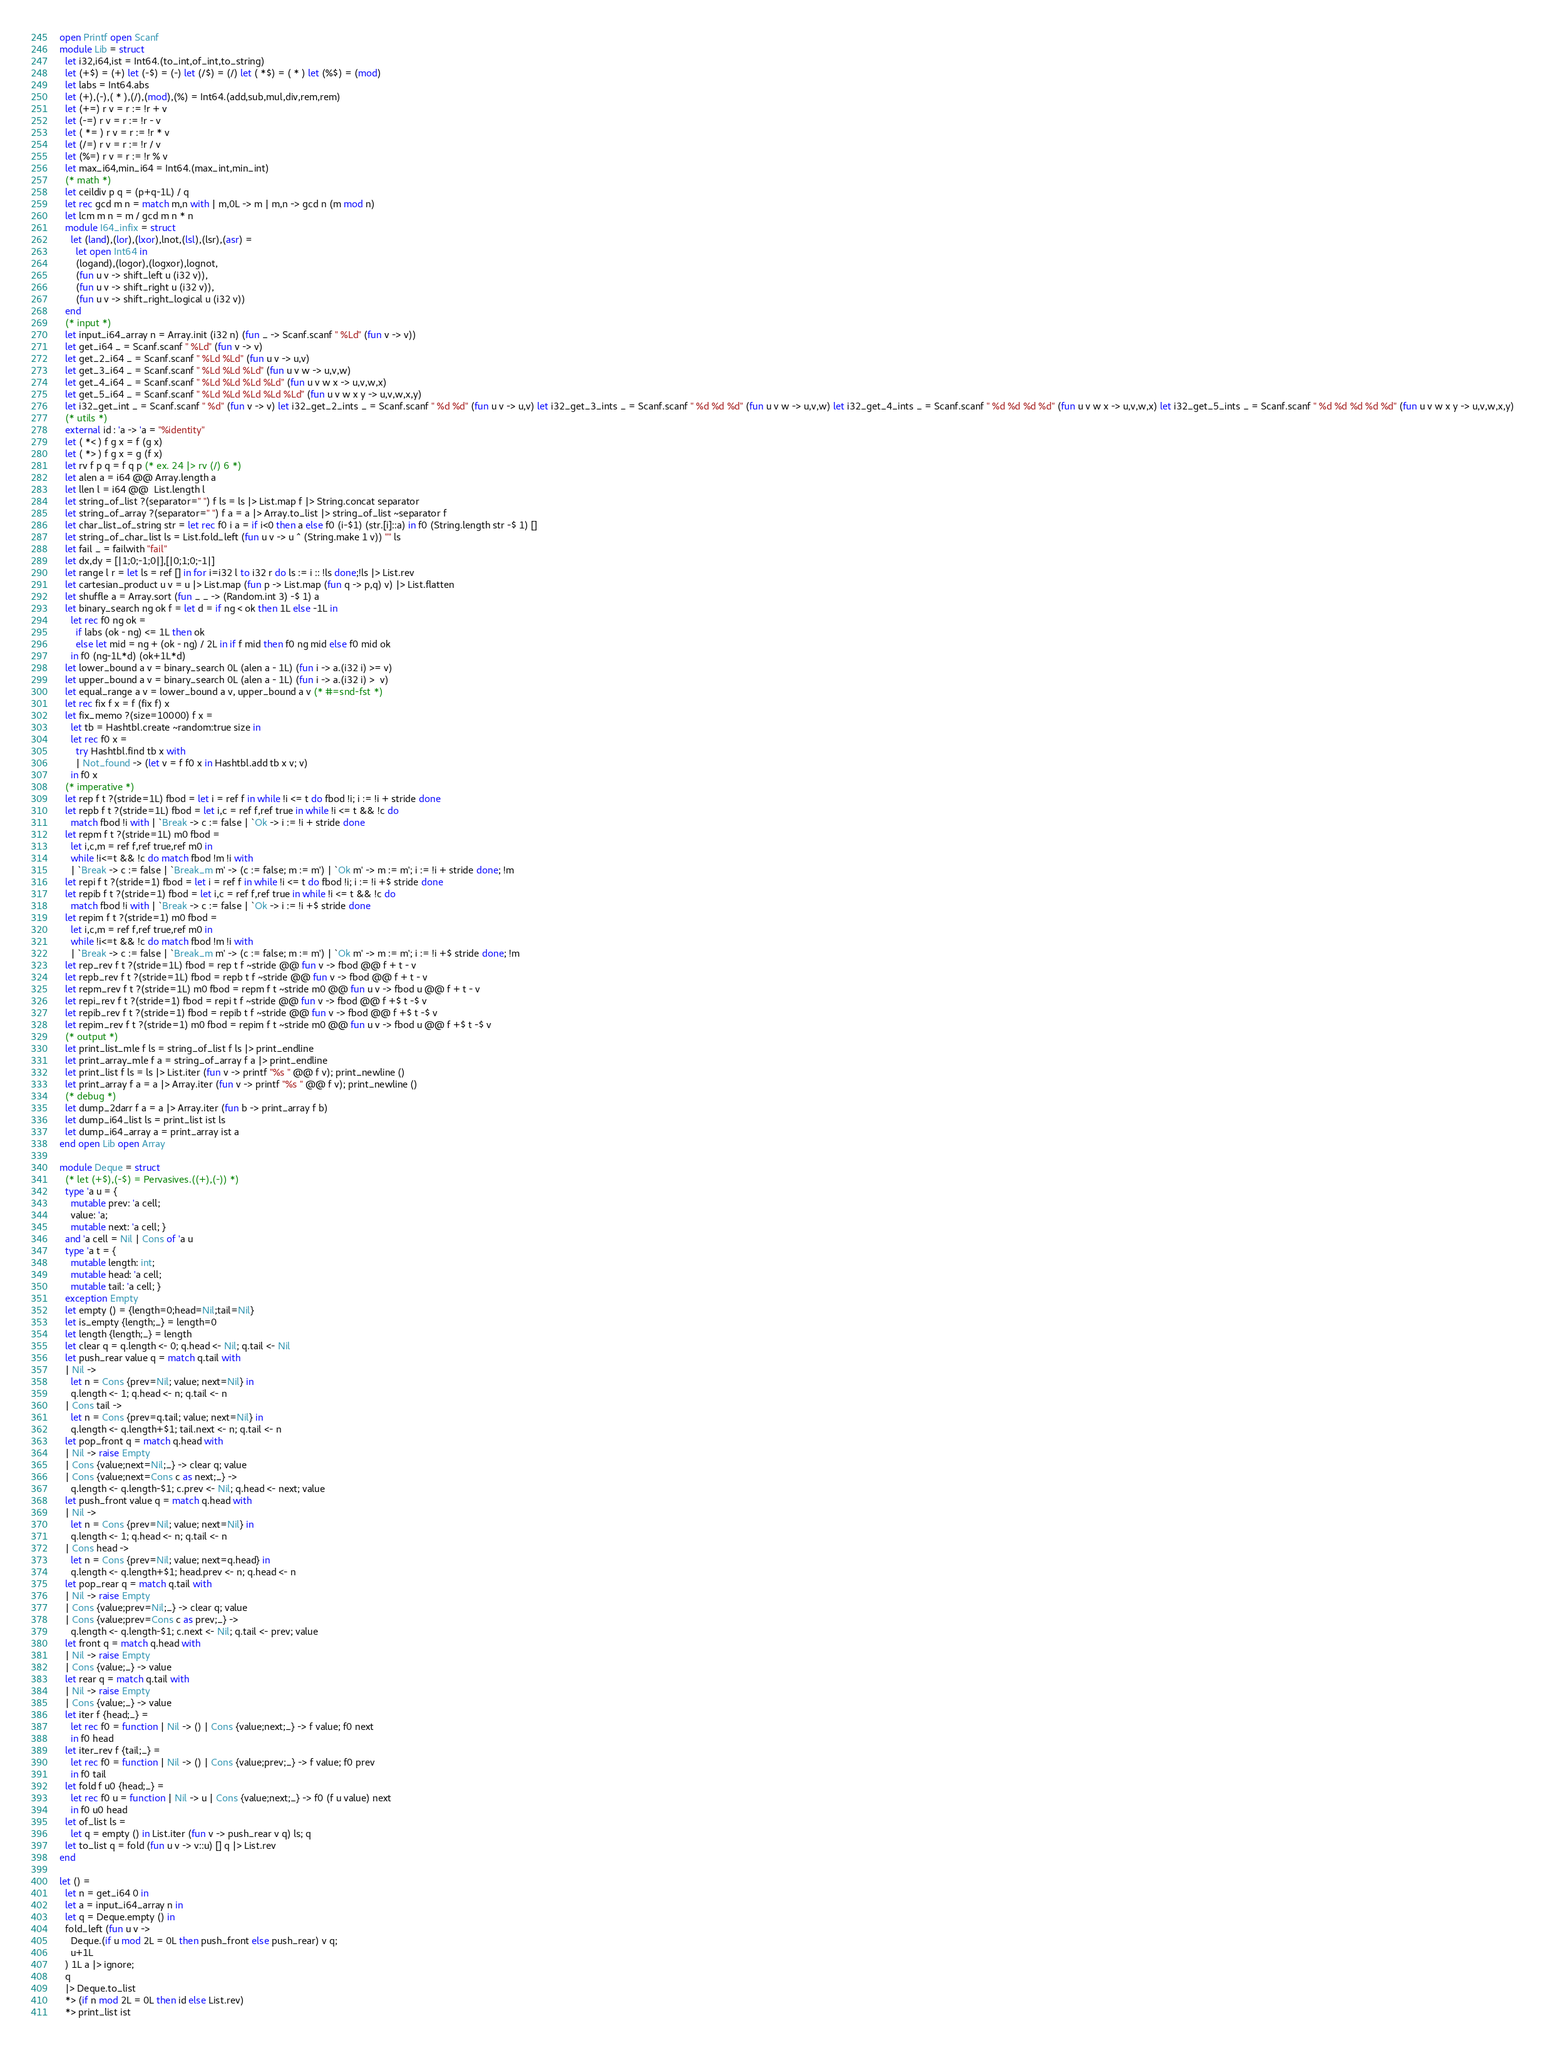<code> <loc_0><loc_0><loc_500><loc_500><_OCaml_>open Printf open Scanf
module Lib = struct
  let i32,i64,ist = Int64.(to_int,of_int,to_string)
  let (+$) = (+) let (-$) = (-) let (/$) = (/) let ( *$) = ( * ) let (%$) = (mod)
  let labs = Int64.abs
  let (+),(-),( * ),(/),(mod),(%) = Int64.(add,sub,mul,div,rem,rem)
  let (+=) r v = r := !r + v
  let (-=) r v = r := !r - v
  let ( *= ) r v = r := !r * v
  let (/=) r v = r := !r / v
  let (%=) r v = r := !r % v
  let max_i64,min_i64 = Int64.(max_int,min_int)
  (* math *)
  let ceildiv p q = (p+q-1L) / q
  let rec gcd m n = match m,n with | m,0L -> m | m,n -> gcd n (m mod n)
  let lcm m n = m / gcd m n * n
  module I64_infix = struct
    let (land),(lor),(lxor),lnot,(lsl),(lsr),(asr) =
      let open Int64 in
      (logand),(logor),(logxor),lognot,
      (fun u v -> shift_left u (i32 v)),
      (fun u v -> shift_right u (i32 v)),
      (fun u v -> shift_right_logical u (i32 v))
  end
  (* input *)
  let input_i64_array n = Array.init (i32 n) (fun _ -> Scanf.scanf " %Ld" (fun v -> v))
  let get_i64 _ = Scanf.scanf " %Ld" (fun v -> v)
  let get_2_i64 _ = Scanf.scanf " %Ld %Ld" (fun u v -> u,v)
  let get_3_i64 _ = Scanf.scanf " %Ld %Ld %Ld" (fun u v w -> u,v,w)
  let get_4_i64 _ = Scanf.scanf " %Ld %Ld %Ld %Ld" (fun u v w x -> u,v,w,x)
  let get_5_i64 _ = Scanf.scanf " %Ld %Ld %Ld %Ld %Ld" (fun u v w x y -> u,v,w,x,y)
  let i32_get_int _ = Scanf.scanf " %d" (fun v -> v) let i32_get_2_ints _ = Scanf.scanf " %d %d" (fun u v -> u,v) let i32_get_3_ints _ = Scanf.scanf " %d %d %d" (fun u v w -> u,v,w) let i32_get_4_ints _ = Scanf.scanf " %d %d %d %d" (fun u v w x -> u,v,w,x) let i32_get_5_ints _ = Scanf.scanf " %d %d %d %d %d" (fun u v w x y -> u,v,w,x,y)
  (* utils *)
  external id : 'a -> 'a = "%identity"
  let ( *< ) f g x = f (g x)
  let ( *> ) f g x = g (f x)
  let rv f p q = f q p (* ex. 24 |> rv (/) 6 *)
  let alen a = i64 @@ Array.length a
  let llen l = i64 @@  List.length l
  let string_of_list ?(separator=" ") f ls = ls |> List.map f |> String.concat separator
  let string_of_array ?(separator=" ") f a = a |> Array.to_list |> string_of_list ~separator f
  let char_list_of_string str = let rec f0 i a = if i<0 then a else f0 (i-$1) (str.[i]::a) in f0 (String.length str -$ 1) []
  let string_of_char_list ls = List.fold_left (fun u v -> u ^ (String.make 1 v)) "" ls
  let fail _ = failwith "fail"
  let dx,dy = [|1;0;-1;0|],[|0;1;0;-1|]
  let range l r = let ls = ref [] in for i=i32 l to i32 r do ls := i :: !ls done;!ls |> List.rev
  let cartesian_product u v = u |> List.map (fun p -> List.map (fun q -> p,q) v) |> List.flatten
  let shuffle a = Array.sort (fun _ _ -> (Random.int 3) -$ 1) a
  let binary_search ng ok f = let d = if ng < ok then 1L else -1L in
    let rec f0 ng ok =
      if labs (ok - ng) <= 1L then ok
      else let mid = ng + (ok - ng) / 2L in if f mid then f0 ng mid else f0 mid ok
    in f0 (ng-1L*d) (ok+1L*d)
  let lower_bound a v = binary_search 0L (alen a - 1L) (fun i -> a.(i32 i) >= v)
  let upper_bound a v = binary_search 0L (alen a - 1L) (fun i -> a.(i32 i) >  v)
  let equal_range a v = lower_bound a v, upper_bound a v (* #=snd-fst *)
  let rec fix f x = f (fix f) x
  let fix_memo ?(size=10000) f x =
    let tb = Hashtbl.create ~random:true size in
    let rec f0 x =
      try Hashtbl.find tb x with
      | Not_found -> (let v = f f0 x in Hashtbl.add tb x v; v)
    in f0 x
  (* imperative *)
  let rep f t ?(stride=1L) fbod = let i = ref f in while !i <= t do fbod !i; i := !i + stride done
  let repb f t ?(stride=1L) fbod = let i,c = ref f,ref true in while !i <= t && !c do
    match fbod !i with | `Break -> c := false | `Ok -> i := !i + stride done
  let repm f t ?(stride=1L) m0 fbod =
    let i,c,m = ref f,ref true,ref m0 in
    while !i<=t && !c do match fbod !m !i with
    | `Break -> c := false | `Break_m m' -> (c := false; m := m') | `Ok m' -> m := m'; i := !i + stride done; !m
  let repi f t ?(stride=1) fbod = let i = ref f in while !i <= t do fbod !i; i := !i +$ stride done
  let repib f t ?(stride=1) fbod = let i,c = ref f,ref true in while !i <= t && !c do
    match fbod !i with | `Break -> c := false | `Ok -> i := !i +$ stride done
  let repim f t ?(stride=1) m0 fbod =
    let i,c,m = ref f,ref true,ref m0 in
    while !i<=t && !c do match fbod !m !i with
    | `Break -> c := false | `Break_m m' -> (c := false; m := m') | `Ok m' -> m := m'; i := !i +$ stride done; !m
  let rep_rev f t ?(stride=1L) fbod = rep t f ~stride @@ fun v -> fbod @@ f + t - v
  let repb_rev f t ?(stride=1L) fbod = repb t f ~stride @@ fun v -> fbod @@ f + t - v
  let repm_rev f t ?(stride=1L) m0 fbod = repm f t ~stride m0 @@ fun u v -> fbod u @@ f + t - v
  let repi_rev f t ?(stride=1) fbod = repi t f ~stride @@ fun v -> fbod @@ f +$ t -$ v
  let repib_rev f t ?(stride=1) fbod = repib t f ~stride @@ fun v -> fbod @@ f +$ t -$ v
  let repim_rev f t ?(stride=1) m0 fbod = repim f t ~stride m0 @@ fun u v -> fbod u @@ f +$ t -$ v
  (* output *)
  let print_list_mle f ls = string_of_list f ls |> print_endline
  let print_array_mle f a = string_of_array f a |> print_endline
  let print_list f ls = ls |> List.iter (fun v -> printf "%s " @@ f v); print_newline ()
  let print_array f a = a |> Array.iter (fun v -> printf "%s " @@ f v); print_newline ()
  (* debug *)
  let dump_2darr f a = a |> Array.iter (fun b -> print_array f b)
  let dump_i64_list ls = print_list ist ls
  let dump_i64_array a = print_array ist a
end open Lib open Array

module Deque = struct
  (* let (+$),(-$) = Pervasives.((+),(-)) *)
  type 'a u = {
    mutable prev: 'a cell;
    value: 'a;
    mutable next: 'a cell; }
  and 'a cell = Nil | Cons of 'a u
  type 'a t = {
    mutable length: int;
    mutable head: 'a cell;
    mutable tail: 'a cell; }
  exception Empty
  let empty () = {length=0;head=Nil;tail=Nil}
  let is_empty {length;_} = length=0
  let length {length;_} = length
  let clear q = q.length <- 0; q.head <- Nil; q.tail <- Nil
  let push_rear value q = match q.tail with
  | Nil ->
    let n = Cons {prev=Nil; value; next=Nil} in
    q.length <- 1; q.head <- n; q.tail <- n
  | Cons tail ->
    let n = Cons {prev=q.tail; value; next=Nil} in
    q.length <- q.length+$1; tail.next <- n; q.tail <- n
  let pop_front q = match q.head with
  | Nil -> raise Empty
  | Cons {value;next=Nil;_} -> clear q; value
  | Cons {value;next=Cons c as next;_} ->
    q.length <- q.length-$1; c.prev <- Nil; q.head <- next; value
  let push_front value q = match q.head with
  | Nil ->
    let n = Cons {prev=Nil; value; next=Nil} in
    q.length <- 1; q.head <- n; q.tail <- n
  | Cons head ->
    let n = Cons {prev=Nil; value; next=q.head} in
    q.length <- q.length+$1; head.prev <- n; q.head <- n
  let pop_rear q = match q.tail with
  | Nil -> raise Empty
  | Cons {value;prev=Nil;_} -> clear q; value
  | Cons {value;prev=Cons c as prev;_} ->
    q.length <- q.length-$1; c.next <- Nil; q.tail <- prev; value
  let front q = match q.head with
  | Nil -> raise Empty
  | Cons {value;_} -> value
  let rear q = match q.tail with
  | Nil -> raise Empty
  | Cons {value;_} -> value
  let iter f {head;_} =
    let rec f0 = function | Nil -> () | Cons {value;next;_} -> f value; f0 next
    in f0 head
  let iter_rev f {tail;_} =
    let rec f0 = function | Nil -> () | Cons {value;prev;_} -> f value; f0 prev
    in f0 tail
  let fold f u0 {head;_} =
    let rec f0 u = function | Nil -> u | Cons {value;next;_} -> f0 (f u value) next
    in f0 u0 head
  let of_list ls =
    let q = empty () in List.iter (fun v -> push_rear v q) ls; q
  let to_list q = fold (fun u v -> v::u) [] q |> List.rev
end

let () =
  let n = get_i64 0 in
  let a = input_i64_array n in
  let q = Deque.empty () in
  fold_left (fun u v ->
    Deque.(if u mod 2L = 0L then push_front else push_rear) v q;
    u+1L
  ) 1L a |> ignore;
  q
  |> Deque.to_list
  *> (if n mod 2L = 0L then id else List.rev)
  *> print_list ist








</code> 